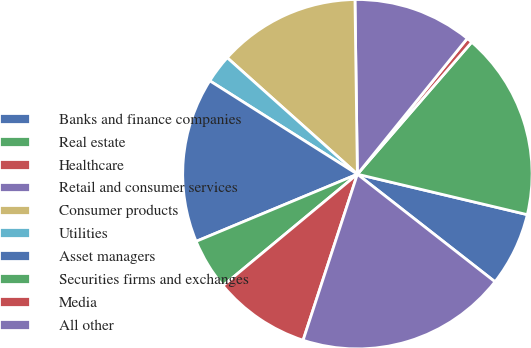Convert chart. <chart><loc_0><loc_0><loc_500><loc_500><pie_chart><fcel>Banks and finance companies<fcel>Real estate<fcel>Healthcare<fcel>Retail and consumer services<fcel>Consumer products<fcel>Utilities<fcel>Asset managers<fcel>Securities firms and exchanges<fcel>Media<fcel>All other<nl><fcel>6.84%<fcel>17.36%<fcel>0.53%<fcel>11.05%<fcel>13.16%<fcel>2.64%<fcel>15.26%<fcel>4.74%<fcel>8.95%<fcel>19.47%<nl></chart> 